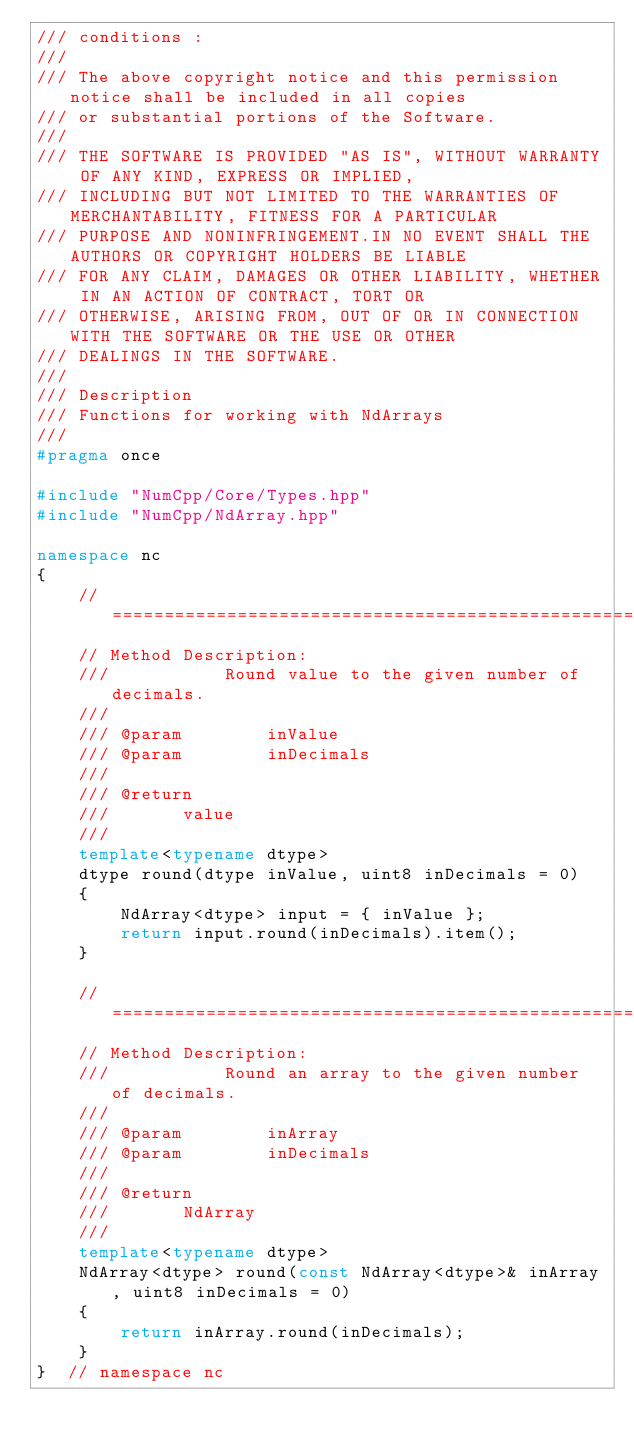<code> <loc_0><loc_0><loc_500><loc_500><_C++_>/// conditions :
///
/// The above copyright notice and this permission notice shall be included in all copies
/// or substantial portions of the Software.
///
/// THE SOFTWARE IS PROVIDED "AS IS", WITHOUT WARRANTY OF ANY KIND, EXPRESS OR IMPLIED,
/// INCLUDING BUT NOT LIMITED TO THE WARRANTIES OF MERCHANTABILITY, FITNESS FOR A PARTICULAR
/// PURPOSE AND NONINFRINGEMENT.IN NO EVENT SHALL THE AUTHORS OR COPYRIGHT HOLDERS BE LIABLE
/// FOR ANY CLAIM, DAMAGES OR OTHER LIABILITY, WHETHER IN AN ACTION OF CONTRACT, TORT OR
/// OTHERWISE, ARISING FROM, OUT OF OR IN CONNECTION WITH THE SOFTWARE OR THE USE OR OTHER
/// DEALINGS IN THE SOFTWARE.
///
/// Description
/// Functions for working with NdArrays
///
#pragma once

#include "NumCpp/Core/Types.hpp"
#include "NumCpp/NdArray.hpp"

namespace nc
{
    //============================================================================
    // Method Description:
    ///						Round value to the given number of decimals.
    ///
    /// @param				inValue
    /// @param				inDecimals
    ///
    /// @return
    ///				value
    ///
    template<typename dtype>
    dtype round(dtype inValue, uint8 inDecimals = 0) 
    {
        NdArray<dtype> input = { inValue };
        return input.round(inDecimals).item();
    }

    //============================================================================
    // Method Description:
    ///						Round an array to the given number of decimals.
    ///
    /// @param				inArray
    /// @param				inDecimals
    ///
    /// @return
    ///				NdArray
    ///
    template<typename dtype>
    NdArray<dtype> round(const NdArray<dtype>& inArray, uint8 inDecimals = 0) 
    {
        return inArray.round(inDecimals);
    }
}  // namespace nc
</code> 